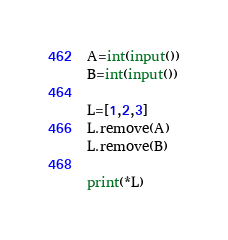Convert code to text. <code><loc_0><loc_0><loc_500><loc_500><_Python_>A=int(input())
B=int(input())

L=[1,2,3]
L.remove(A)
L.remove(B)

print(*L)</code> 